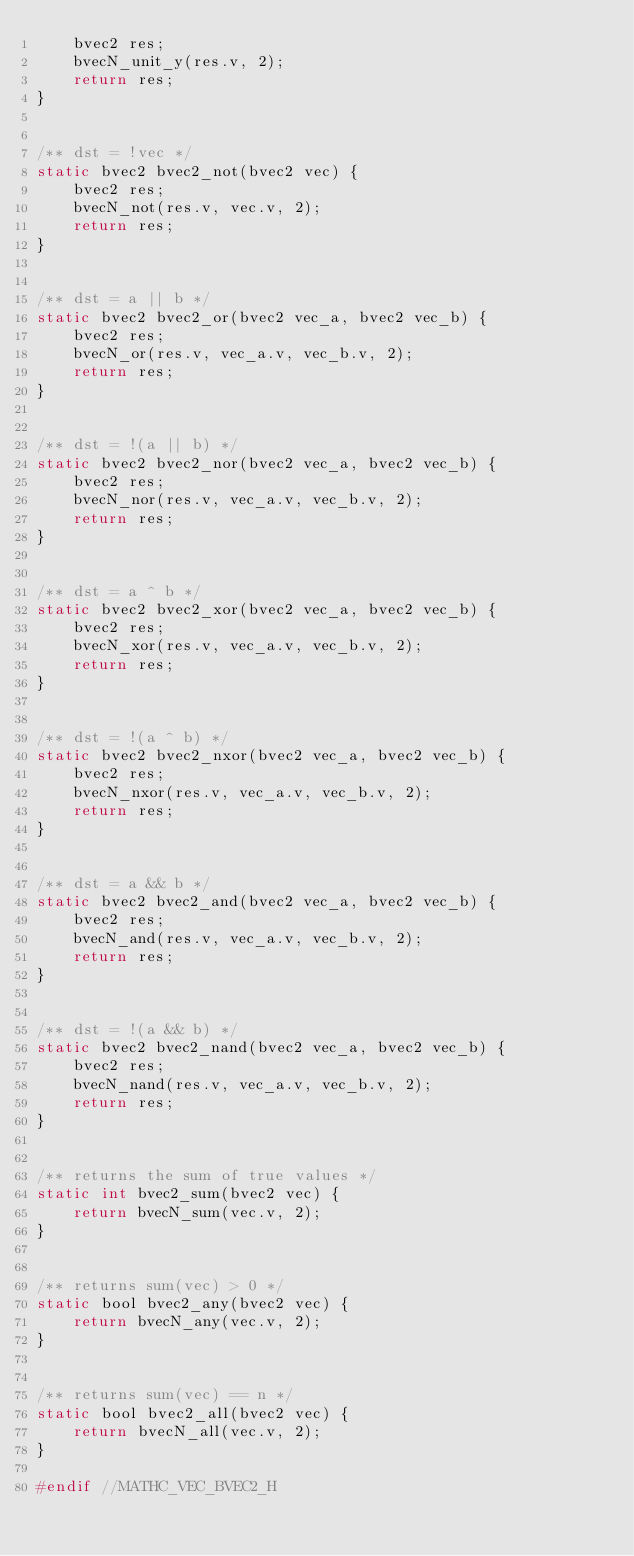<code> <loc_0><loc_0><loc_500><loc_500><_C_>    bvec2 res;
    bvecN_unit_y(res.v, 2);
    return res;
}


/** dst = !vec */
static bvec2 bvec2_not(bvec2 vec) {
    bvec2 res;
    bvecN_not(res.v, vec.v, 2);
    return res;
}


/** dst = a || b */
static bvec2 bvec2_or(bvec2 vec_a, bvec2 vec_b) {
    bvec2 res;
    bvecN_or(res.v, vec_a.v, vec_b.v, 2);
    return res;
}


/** dst = !(a || b) */
static bvec2 bvec2_nor(bvec2 vec_a, bvec2 vec_b) {
    bvec2 res;
    bvecN_nor(res.v, vec_a.v, vec_b.v, 2);
    return res;
}


/** dst = a ^ b */
static bvec2 bvec2_xor(bvec2 vec_a, bvec2 vec_b) {
    bvec2 res;
    bvecN_xor(res.v, vec_a.v, vec_b.v, 2);
    return res;
}


/** dst = !(a ^ b) */
static bvec2 bvec2_nxor(bvec2 vec_a, bvec2 vec_b) {
    bvec2 res;
    bvecN_nxor(res.v, vec_a.v, vec_b.v, 2);
    return res;
}


/** dst = a && b */
static bvec2 bvec2_and(bvec2 vec_a, bvec2 vec_b) {
    bvec2 res;
    bvecN_and(res.v, vec_a.v, vec_b.v, 2);
    return res;
}


/** dst = !(a && b) */
static bvec2 bvec2_nand(bvec2 vec_a, bvec2 vec_b) {
    bvec2 res;
    bvecN_nand(res.v, vec_a.v, vec_b.v, 2);
    return res;
}


/** returns the sum of true values */
static int bvec2_sum(bvec2 vec) {
    return bvecN_sum(vec.v, 2);
}


/** returns sum(vec) > 0 */
static bool bvec2_any(bvec2 vec) {
    return bvecN_any(vec.v, 2);
}


/** returns sum(vec) == n */
static bool bvec2_all(bvec2 vec) {
    return bvecN_all(vec.v, 2);
}

#endif //MATHC_VEC_BVEC2_H
</code> 